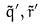Convert formula to latex. <formula><loc_0><loc_0><loc_500><loc_500>\tilde { q } ^ { \prime } , \tilde { r } ^ { \prime }</formula> 